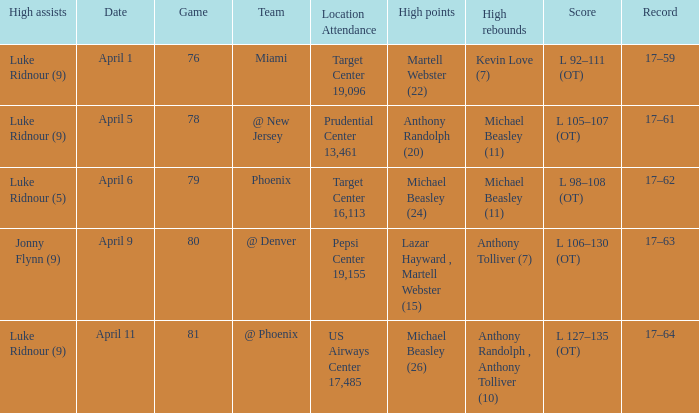Who did the most high rebounds on April 6? Michael Beasley (11). 